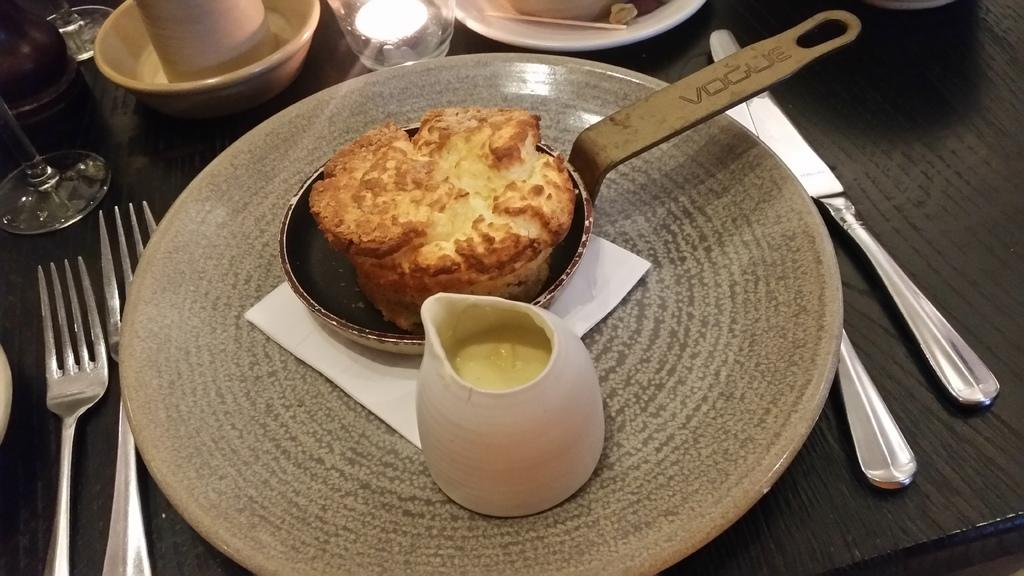What type of utensils are on the table in the image? There is a knife and forks on the table in the image. What type of tableware is on the table in the image? There are glasses, a bowl, and plates on the table in the image. What is the purpose of the items on the table in the image? The items on the table are used for eating and serving food. What type of food is on the table in the image? There is unspecified food on the table in the image. Can you tell me how many houses are on the table in the image? There are no houses present on the table in the image. What type of calculator is on the table in the image? There is no calculator present on the table in the image. 